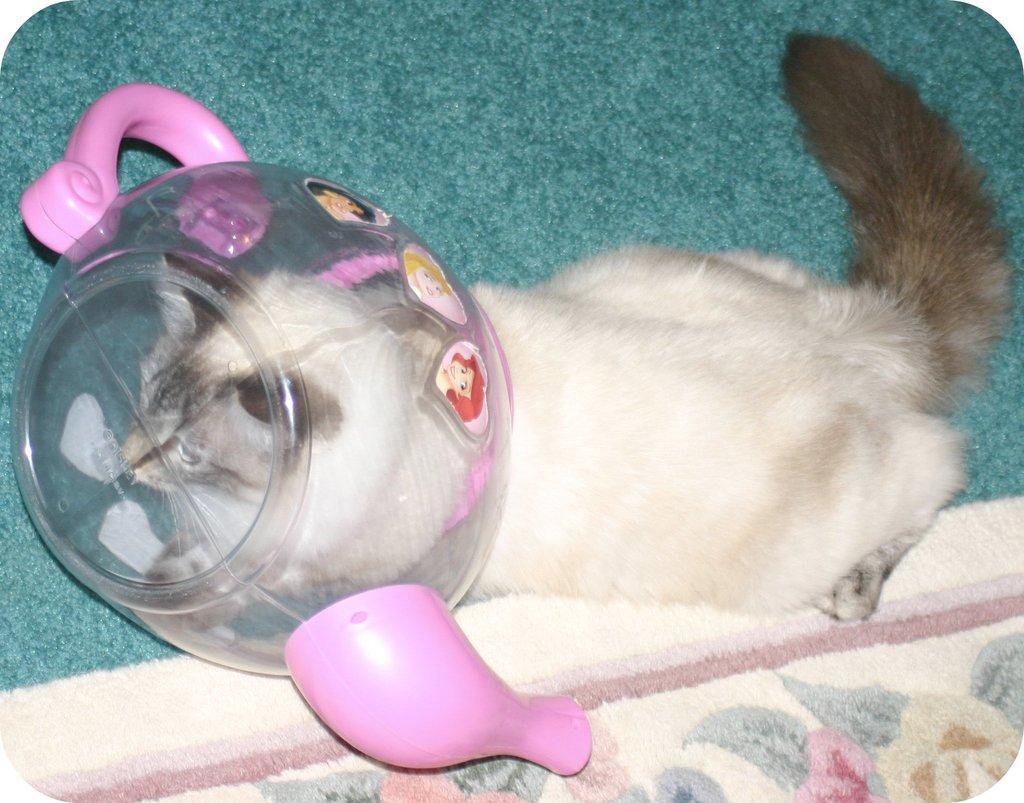Describe this image in one or two sentences. This picture shows a cat and we see a plastic jar its head. The cat is white and black in color and we see carpets. 